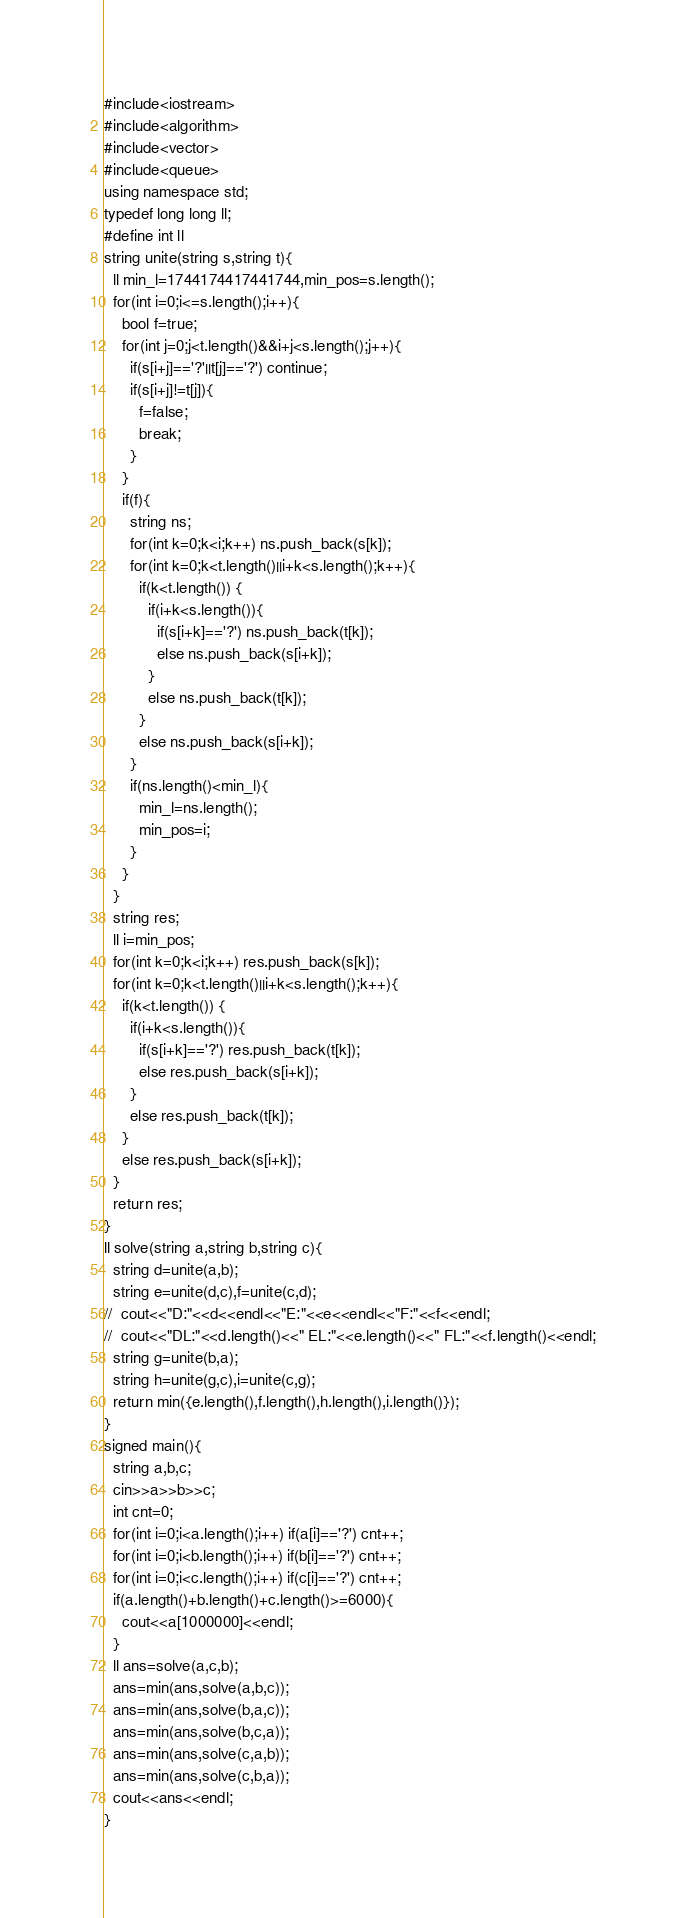Convert code to text. <code><loc_0><loc_0><loc_500><loc_500><_C++_>#include<iostream>
#include<algorithm>
#include<vector>
#include<queue>
using namespace std;
typedef long long ll;
#define int ll
string unite(string s,string t){
  ll min_l=1744174417441744,min_pos=s.length();
  for(int i=0;i<=s.length();i++){
    bool f=true;
    for(int j=0;j<t.length()&&i+j<s.length();j++){
      if(s[i+j]=='?'||t[j]=='?') continue;
      if(s[i+j]!=t[j]){
        f=false;
        break;
      }
    }
    if(f){
      string ns;
      for(int k=0;k<i;k++) ns.push_back(s[k]);
      for(int k=0;k<t.length()||i+k<s.length();k++){
        if(k<t.length()) {
          if(i+k<s.length()){
            if(s[i+k]=='?') ns.push_back(t[k]);
            else ns.push_back(s[i+k]);
          }
          else ns.push_back(t[k]);
        }
        else ns.push_back(s[i+k]);
      }
      if(ns.length()<min_l){
        min_l=ns.length();
        min_pos=i;
      }
    }
  }
  string res;
  ll i=min_pos;
  for(int k=0;k<i;k++) res.push_back(s[k]);
  for(int k=0;k<t.length()||i+k<s.length();k++){
    if(k<t.length()) {
      if(i+k<s.length()){
        if(s[i+k]=='?') res.push_back(t[k]);
        else res.push_back(s[i+k]);
      }
      else res.push_back(t[k]);
    }
    else res.push_back(s[i+k]);
  }
  return res;
}
ll solve(string a,string b,string c){
  string d=unite(a,b);
  string e=unite(d,c),f=unite(c,d);
//  cout<<"D:"<<d<<endl<<"E:"<<e<<endl<<"F:"<<f<<endl;
//  cout<<"DL:"<<d.length()<<" EL:"<<e.length()<<" FL:"<<f.length()<<endl;
  string g=unite(b,a);
  string h=unite(g,c),i=unite(c,g);
  return min({e.length(),f.length(),h.length(),i.length()});
}
signed main(){
  string a,b,c;
  cin>>a>>b>>c;
  int cnt=0;
  for(int i=0;i<a.length();i++) if(a[i]=='?') cnt++;
  for(int i=0;i<b.length();i++) if(b[i]=='?') cnt++;
  for(int i=0;i<c.length();i++) if(c[i]=='?') cnt++;
  if(a.length()+b.length()+c.length()>=6000){
    cout<<a[1000000]<<endl;
  }
  ll ans=solve(a,c,b);
  ans=min(ans,solve(a,b,c));
  ans=min(ans,solve(b,a,c));
  ans=min(ans,solve(b,c,a));
  ans=min(ans,solve(c,a,b));
  ans=min(ans,solve(c,b,a));
  cout<<ans<<endl;
}
</code> 